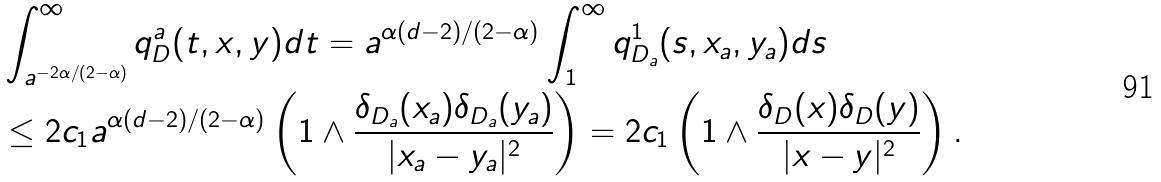<formula> <loc_0><loc_0><loc_500><loc_500>& \int _ { a ^ { - 2 \alpha / ( 2 - \alpha ) } } ^ { \infty } q ^ { a } _ { D } ( t , x , y ) d t = a ^ { \alpha ( d - 2 ) / ( 2 - \alpha ) } \int _ { 1 } ^ { \infty } q ^ { 1 } _ { D _ { a } } ( s , x _ { a } , y _ { a } ) d s \\ & \leq 2 c _ { 1 } a ^ { \alpha ( d - 2 ) / ( 2 - \alpha ) } \left ( 1 \wedge \frac { \delta _ { D _ { a } } ( x _ { a } ) \delta _ { D _ { a } } ( y _ { a } ) } { | x _ { a } - y _ { a } | ^ { 2 } } \right ) = 2 c _ { 1 } \left ( 1 \wedge \frac { \delta _ { D } ( x ) \delta _ { D } ( y ) } { | x - y | ^ { 2 } } \right ) .</formula> 